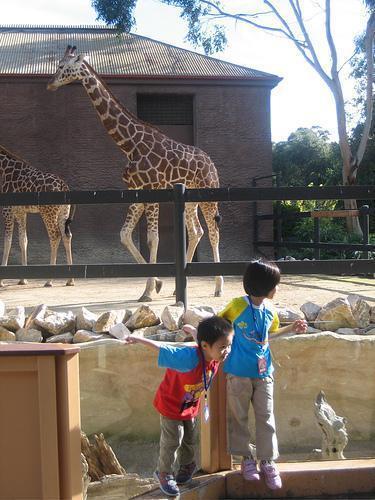How many kids are there?
Give a very brief answer. 2. How many people are there?
Give a very brief answer. 2. How many giraffes are in the picture?
Give a very brief answer. 2. How many trains have a number on the front?
Give a very brief answer. 0. 